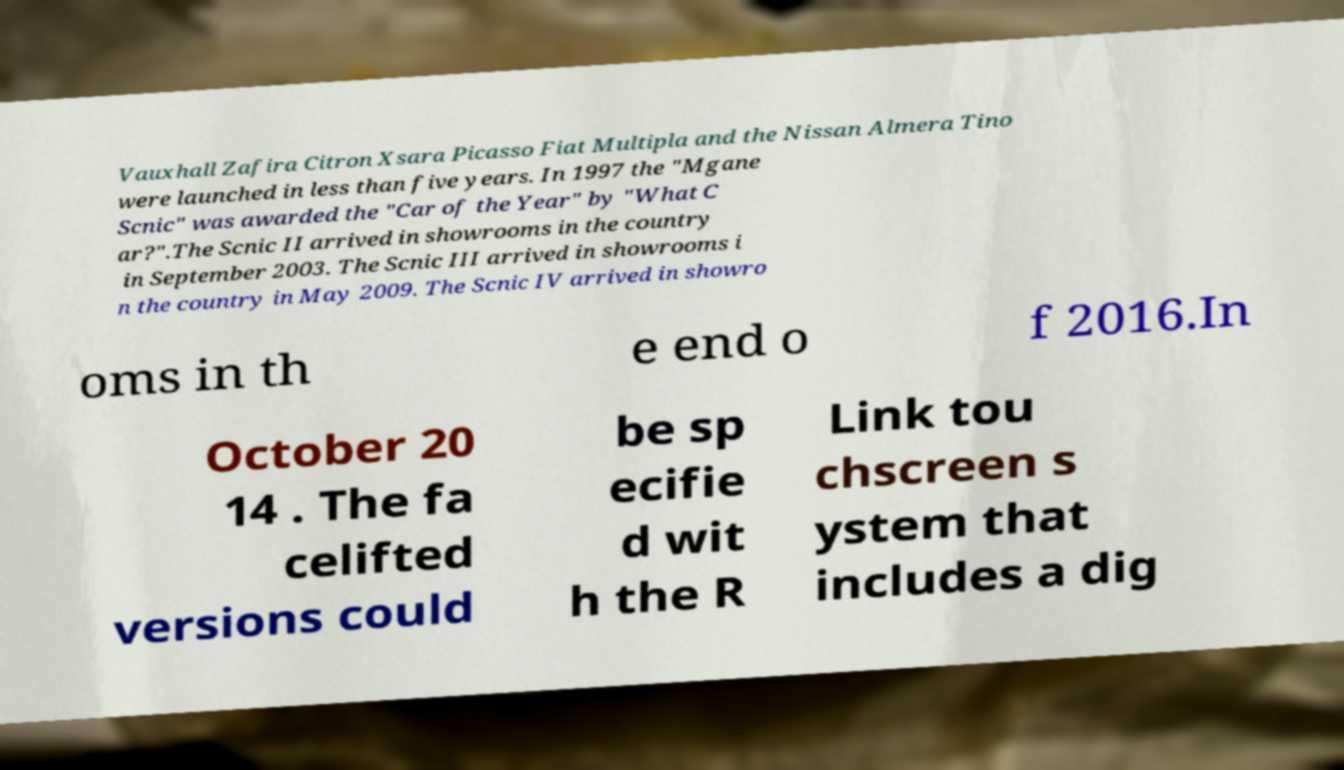Could you assist in decoding the text presented in this image and type it out clearly? Vauxhall Zafira Citron Xsara Picasso Fiat Multipla and the Nissan Almera Tino were launched in less than five years. In 1997 the "Mgane Scnic" was awarded the "Car of the Year" by "What C ar?".The Scnic II arrived in showrooms in the country in September 2003. The Scnic III arrived in showrooms i n the country in May 2009. The Scnic IV arrived in showro oms in th e end o f 2016.In October 20 14 . The fa celifted versions could be sp ecifie d wit h the R Link tou chscreen s ystem that includes a dig 